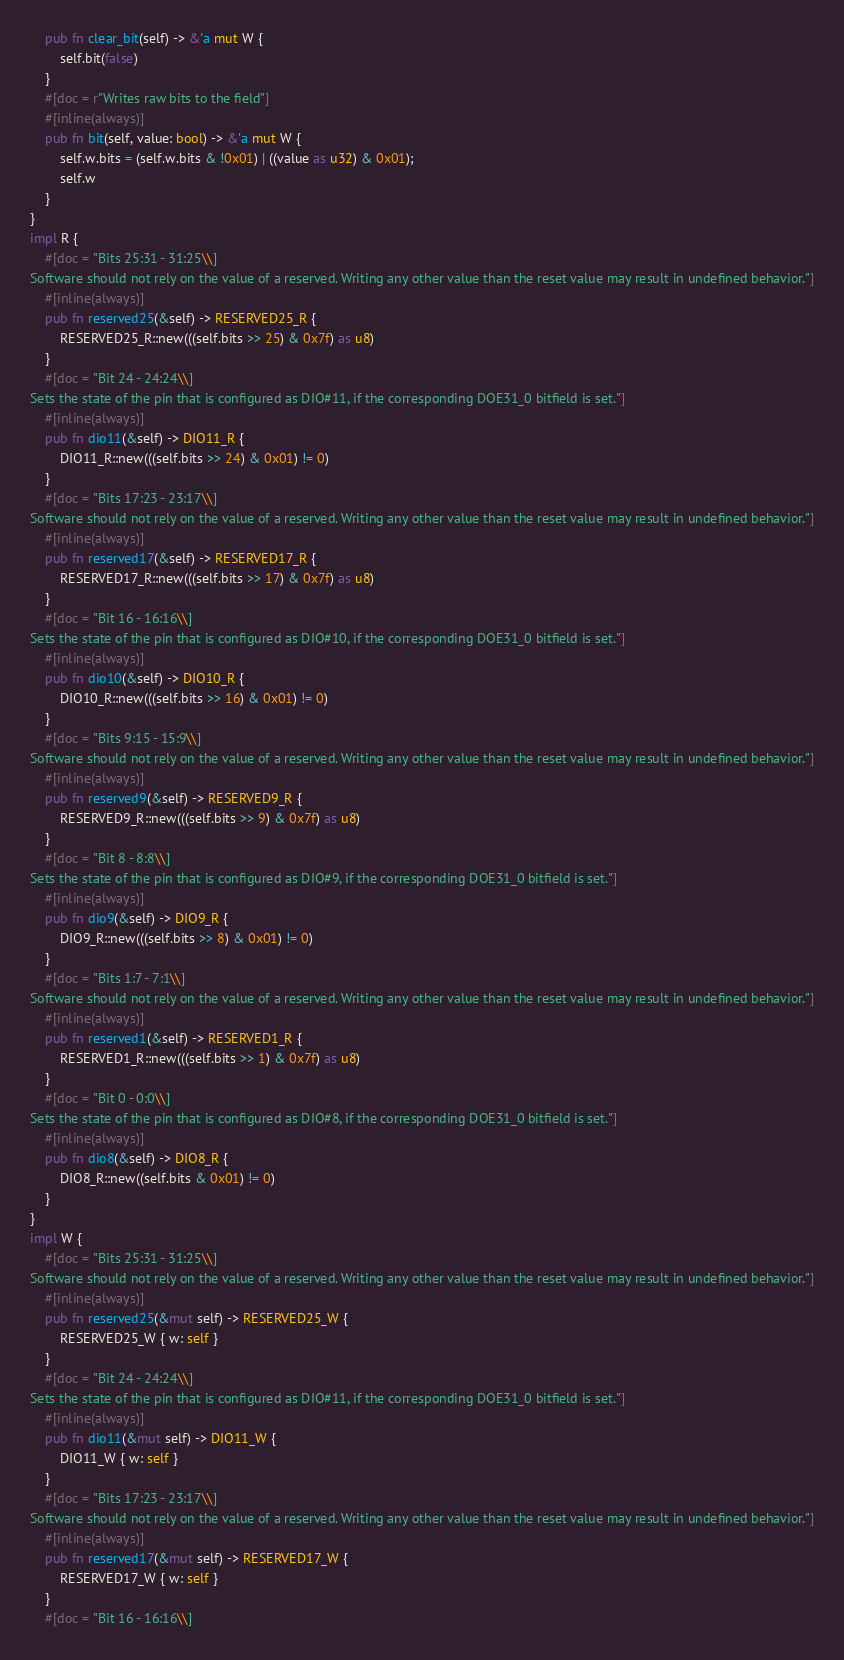Convert code to text. <code><loc_0><loc_0><loc_500><loc_500><_Rust_>    pub fn clear_bit(self) -> &'a mut W {
        self.bit(false)
    }
    #[doc = r"Writes raw bits to the field"]
    #[inline(always)]
    pub fn bit(self, value: bool) -> &'a mut W {
        self.w.bits = (self.w.bits & !0x01) | ((value as u32) & 0x01);
        self.w
    }
}
impl R {
    #[doc = "Bits 25:31 - 31:25\\]
Software should not rely on the value of a reserved. Writing any other value than the reset value may result in undefined behavior."]
    #[inline(always)]
    pub fn reserved25(&self) -> RESERVED25_R {
        RESERVED25_R::new(((self.bits >> 25) & 0x7f) as u8)
    }
    #[doc = "Bit 24 - 24:24\\]
Sets the state of the pin that is configured as DIO#11, if the corresponding DOE31_0 bitfield is set."]
    #[inline(always)]
    pub fn dio11(&self) -> DIO11_R {
        DIO11_R::new(((self.bits >> 24) & 0x01) != 0)
    }
    #[doc = "Bits 17:23 - 23:17\\]
Software should not rely on the value of a reserved. Writing any other value than the reset value may result in undefined behavior."]
    #[inline(always)]
    pub fn reserved17(&self) -> RESERVED17_R {
        RESERVED17_R::new(((self.bits >> 17) & 0x7f) as u8)
    }
    #[doc = "Bit 16 - 16:16\\]
Sets the state of the pin that is configured as DIO#10, if the corresponding DOE31_0 bitfield is set."]
    #[inline(always)]
    pub fn dio10(&self) -> DIO10_R {
        DIO10_R::new(((self.bits >> 16) & 0x01) != 0)
    }
    #[doc = "Bits 9:15 - 15:9\\]
Software should not rely on the value of a reserved. Writing any other value than the reset value may result in undefined behavior."]
    #[inline(always)]
    pub fn reserved9(&self) -> RESERVED9_R {
        RESERVED9_R::new(((self.bits >> 9) & 0x7f) as u8)
    }
    #[doc = "Bit 8 - 8:8\\]
Sets the state of the pin that is configured as DIO#9, if the corresponding DOE31_0 bitfield is set."]
    #[inline(always)]
    pub fn dio9(&self) -> DIO9_R {
        DIO9_R::new(((self.bits >> 8) & 0x01) != 0)
    }
    #[doc = "Bits 1:7 - 7:1\\]
Software should not rely on the value of a reserved. Writing any other value than the reset value may result in undefined behavior."]
    #[inline(always)]
    pub fn reserved1(&self) -> RESERVED1_R {
        RESERVED1_R::new(((self.bits >> 1) & 0x7f) as u8)
    }
    #[doc = "Bit 0 - 0:0\\]
Sets the state of the pin that is configured as DIO#8, if the corresponding DOE31_0 bitfield is set."]
    #[inline(always)]
    pub fn dio8(&self) -> DIO8_R {
        DIO8_R::new((self.bits & 0x01) != 0)
    }
}
impl W {
    #[doc = "Bits 25:31 - 31:25\\]
Software should not rely on the value of a reserved. Writing any other value than the reset value may result in undefined behavior."]
    #[inline(always)]
    pub fn reserved25(&mut self) -> RESERVED25_W {
        RESERVED25_W { w: self }
    }
    #[doc = "Bit 24 - 24:24\\]
Sets the state of the pin that is configured as DIO#11, if the corresponding DOE31_0 bitfield is set."]
    #[inline(always)]
    pub fn dio11(&mut self) -> DIO11_W {
        DIO11_W { w: self }
    }
    #[doc = "Bits 17:23 - 23:17\\]
Software should not rely on the value of a reserved. Writing any other value than the reset value may result in undefined behavior."]
    #[inline(always)]
    pub fn reserved17(&mut self) -> RESERVED17_W {
        RESERVED17_W { w: self }
    }
    #[doc = "Bit 16 - 16:16\\]</code> 